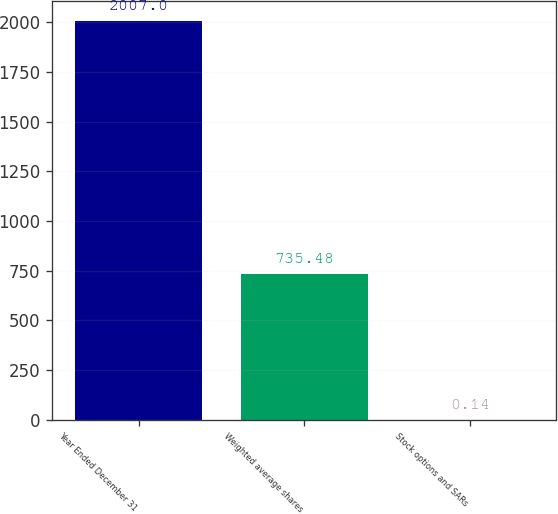Convert chart. <chart><loc_0><loc_0><loc_500><loc_500><bar_chart><fcel>Year Ended December 31<fcel>Weighted average shares<fcel>Stock options and SARs<nl><fcel>2007<fcel>735.48<fcel>0.14<nl></chart> 